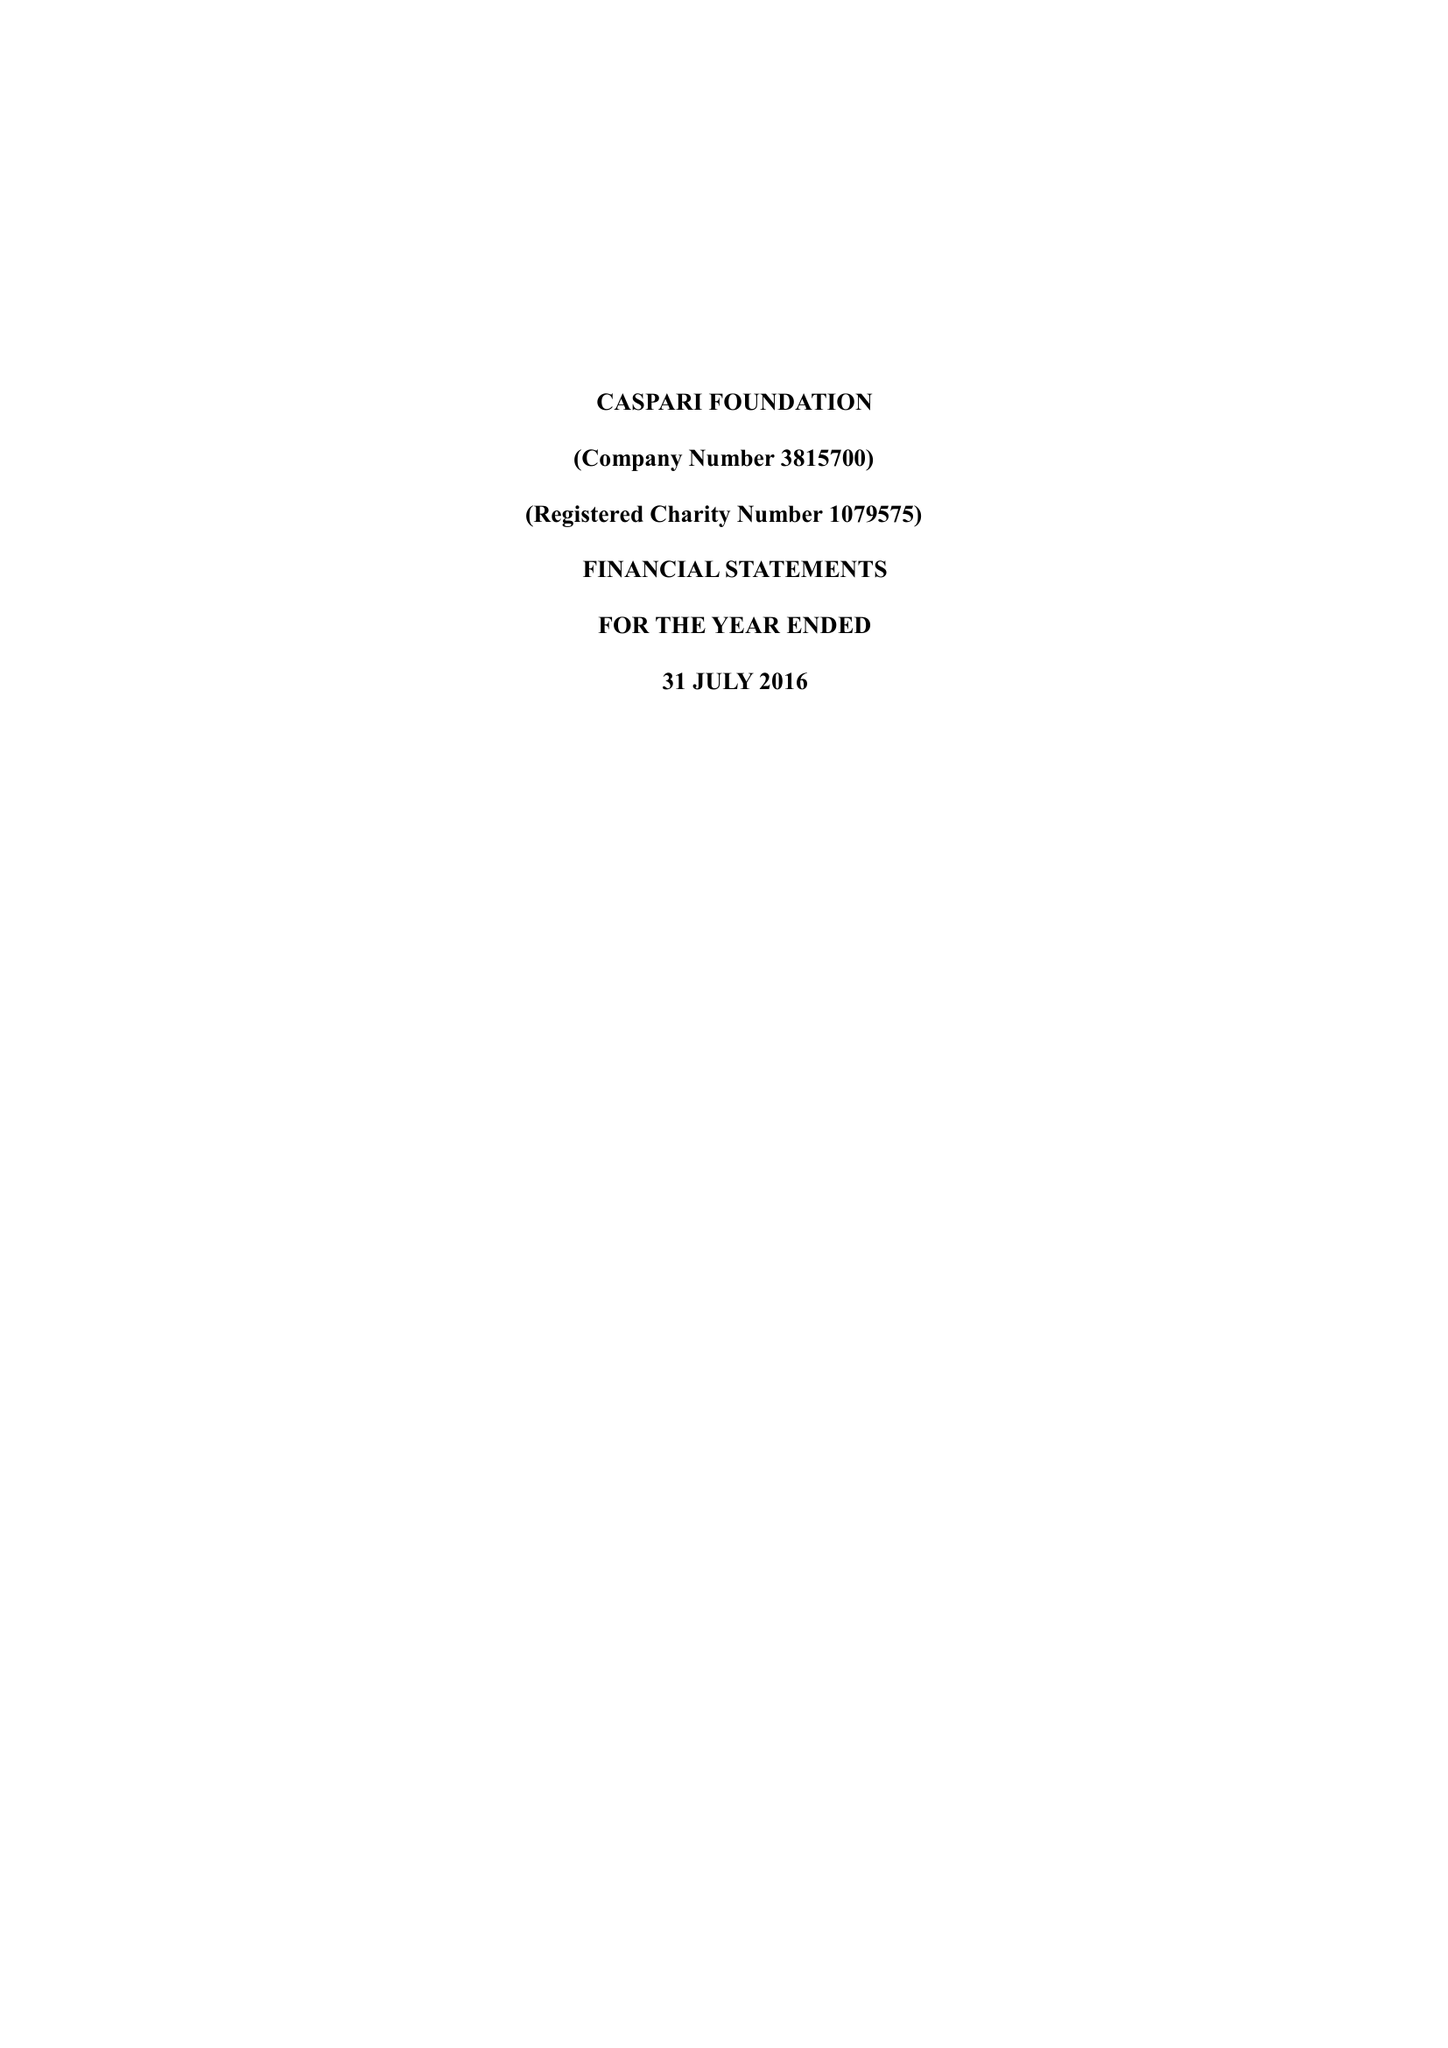What is the value for the income_annually_in_british_pounds?
Answer the question using a single word or phrase. 192316.00 